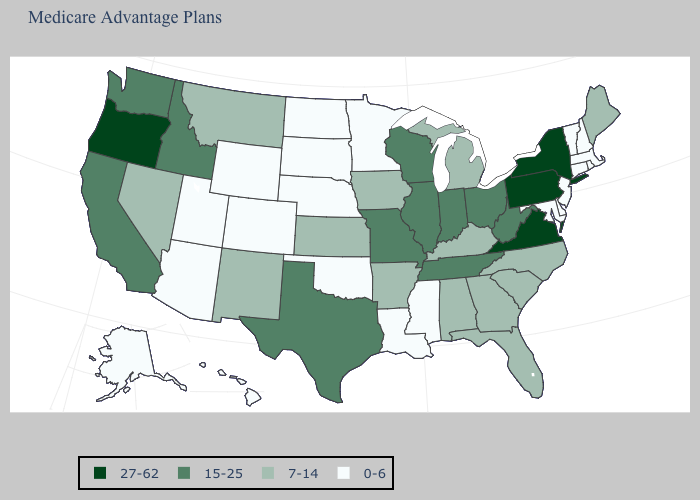Does the map have missing data?
Short answer required. No. Does the map have missing data?
Concise answer only. No. Which states have the lowest value in the MidWest?
Write a very short answer. Minnesota, North Dakota, Nebraska, South Dakota. What is the value of Oregon?
Quick response, please. 27-62. Does West Virginia have the highest value in the USA?
Give a very brief answer. No. Which states have the lowest value in the South?
Write a very short answer. Delaware, Louisiana, Maryland, Mississippi, Oklahoma. Does Arizona have a lower value than Oklahoma?
Write a very short answer. No. Is the legend a continuous bar?
Keep it brief. No. Which states have the highest value in the USA?
Answer briefly. New York, Oregon, Pennsylvania, Virginia. Name the states that have a value in the range 27-62?
Write a very short answer. New York, Oregon, Pennsylvania, Virginia. What is the value of Florida?
Give a very brief answer. 7-14. Does New Mexico have the lowest value in the West?
Concise answer only. No. Is the legend a continuous bar?
Be succinct. No. What is the value of Pennsylvania?
Short answer required. 27-62. Among the states that border Wyoming , which have the highest value?
Give a very brief answer. Idaho. 